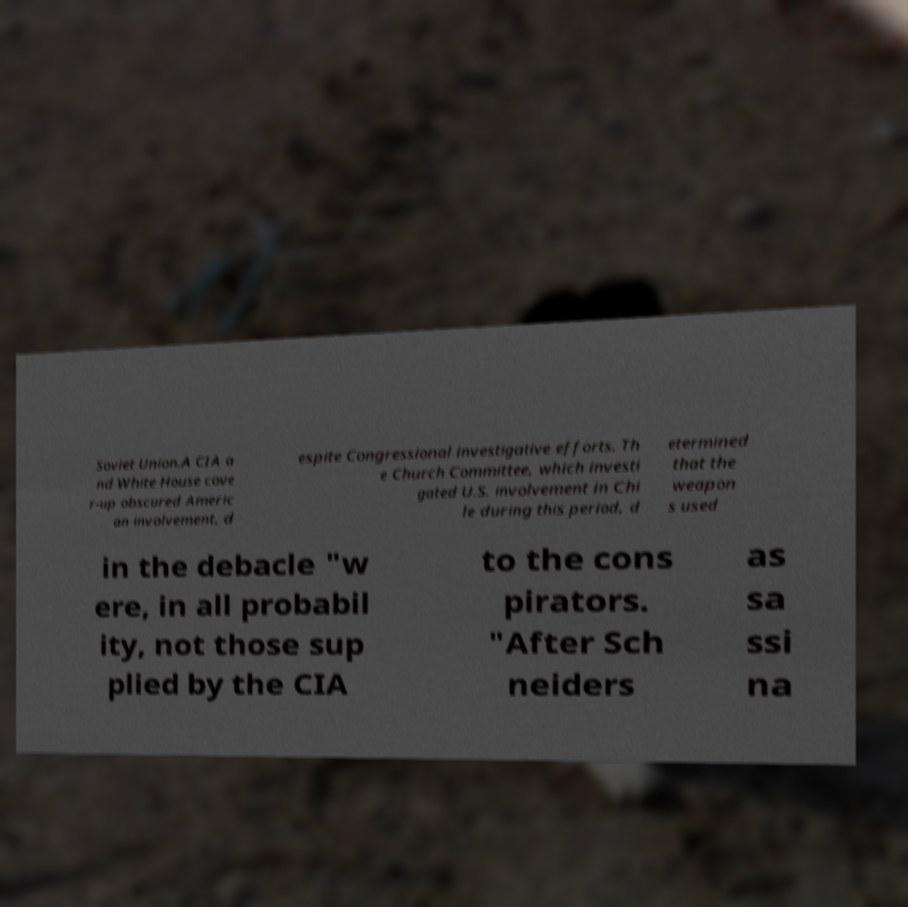What messages or text are displayed in this image? I need them in a readable, typed format. Soviet Union.A CIA a nd White House cove r-up obscured Americ an involvement, d espite Congressional investigative efforts. Th e Church Committee, which investi gated U.S. involvement in Chi le during this period, d etermined that the weapon s used in the debacle "w ere, in all probabil ity, not those sup plied by the CIA to the cons pirators. "After Sch neiders as sa ssi na 